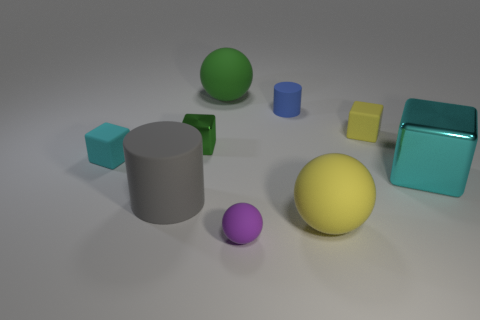What number of other objects are there of the same color as the large matte cylinder?
Your answer should be compact. 0. Is the number of small matte cubes less than the number of tiny yellow things?
Your response must be concise. No. There is a sphere that is both in front of the big gray matte cylinder and behind the small purple sphere; what color is it?
Offer a very short reply. Yellow. There is another cyan thing that is the same shape as the large cyan object; what is it made of?
Give a very brief answer. Rubber. Is there any other thing that is the same size as the blue rubber thing?
Your response must be concise. Yes. Is the number of brown rubber cubes greater than the number of small purple objects?
Offer a terse response. No. How big is the matte ball that is to the left of the yellow rubber ball and to the right of the green matte thing?
Make the answer very short. Small. What shape is the tiny purple thing?
Make the answer very short. Sphere. How many tiny blue matte objects are the same shape as the large cyan object?
Your response must be concise. 0. Are there fewer shiny things that are behind the small metallic cube than green metallic blocks that are in front of the large cyan metal object?
Give a very brief answer. No. 